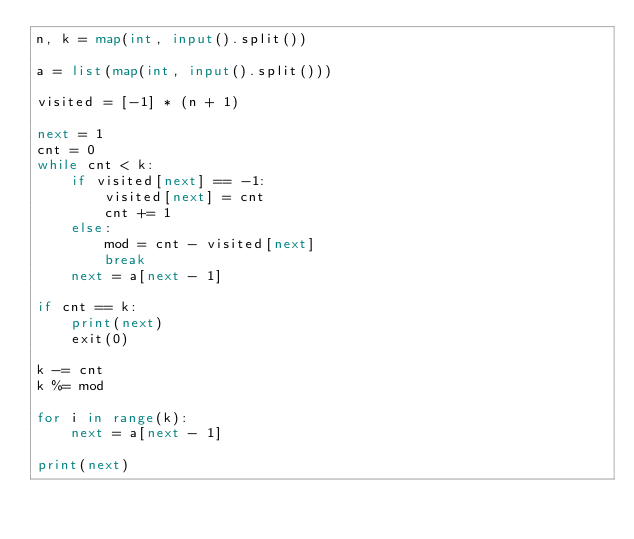Convert code to text. <code><loc_0><loc_0><loc_500><loc_500><_Python_>n, k = map(int, input().split())

a = list(map(int, input().split()))

visited = [-1] * (n + 1)

next = 1
cnt = 0
while cnt < k:
    if visited[next] == -1:
        visited[next] = cnt
        cnt += 1
    else:
        mod = cnt - visited[next]
        break
    next = a[next - 1]

if cnt == k:
    print(next)
    exit(0)

k -= cnt
k %= mod

for i in range(k):
    next = a[next - 1]

print(next)
</code> 